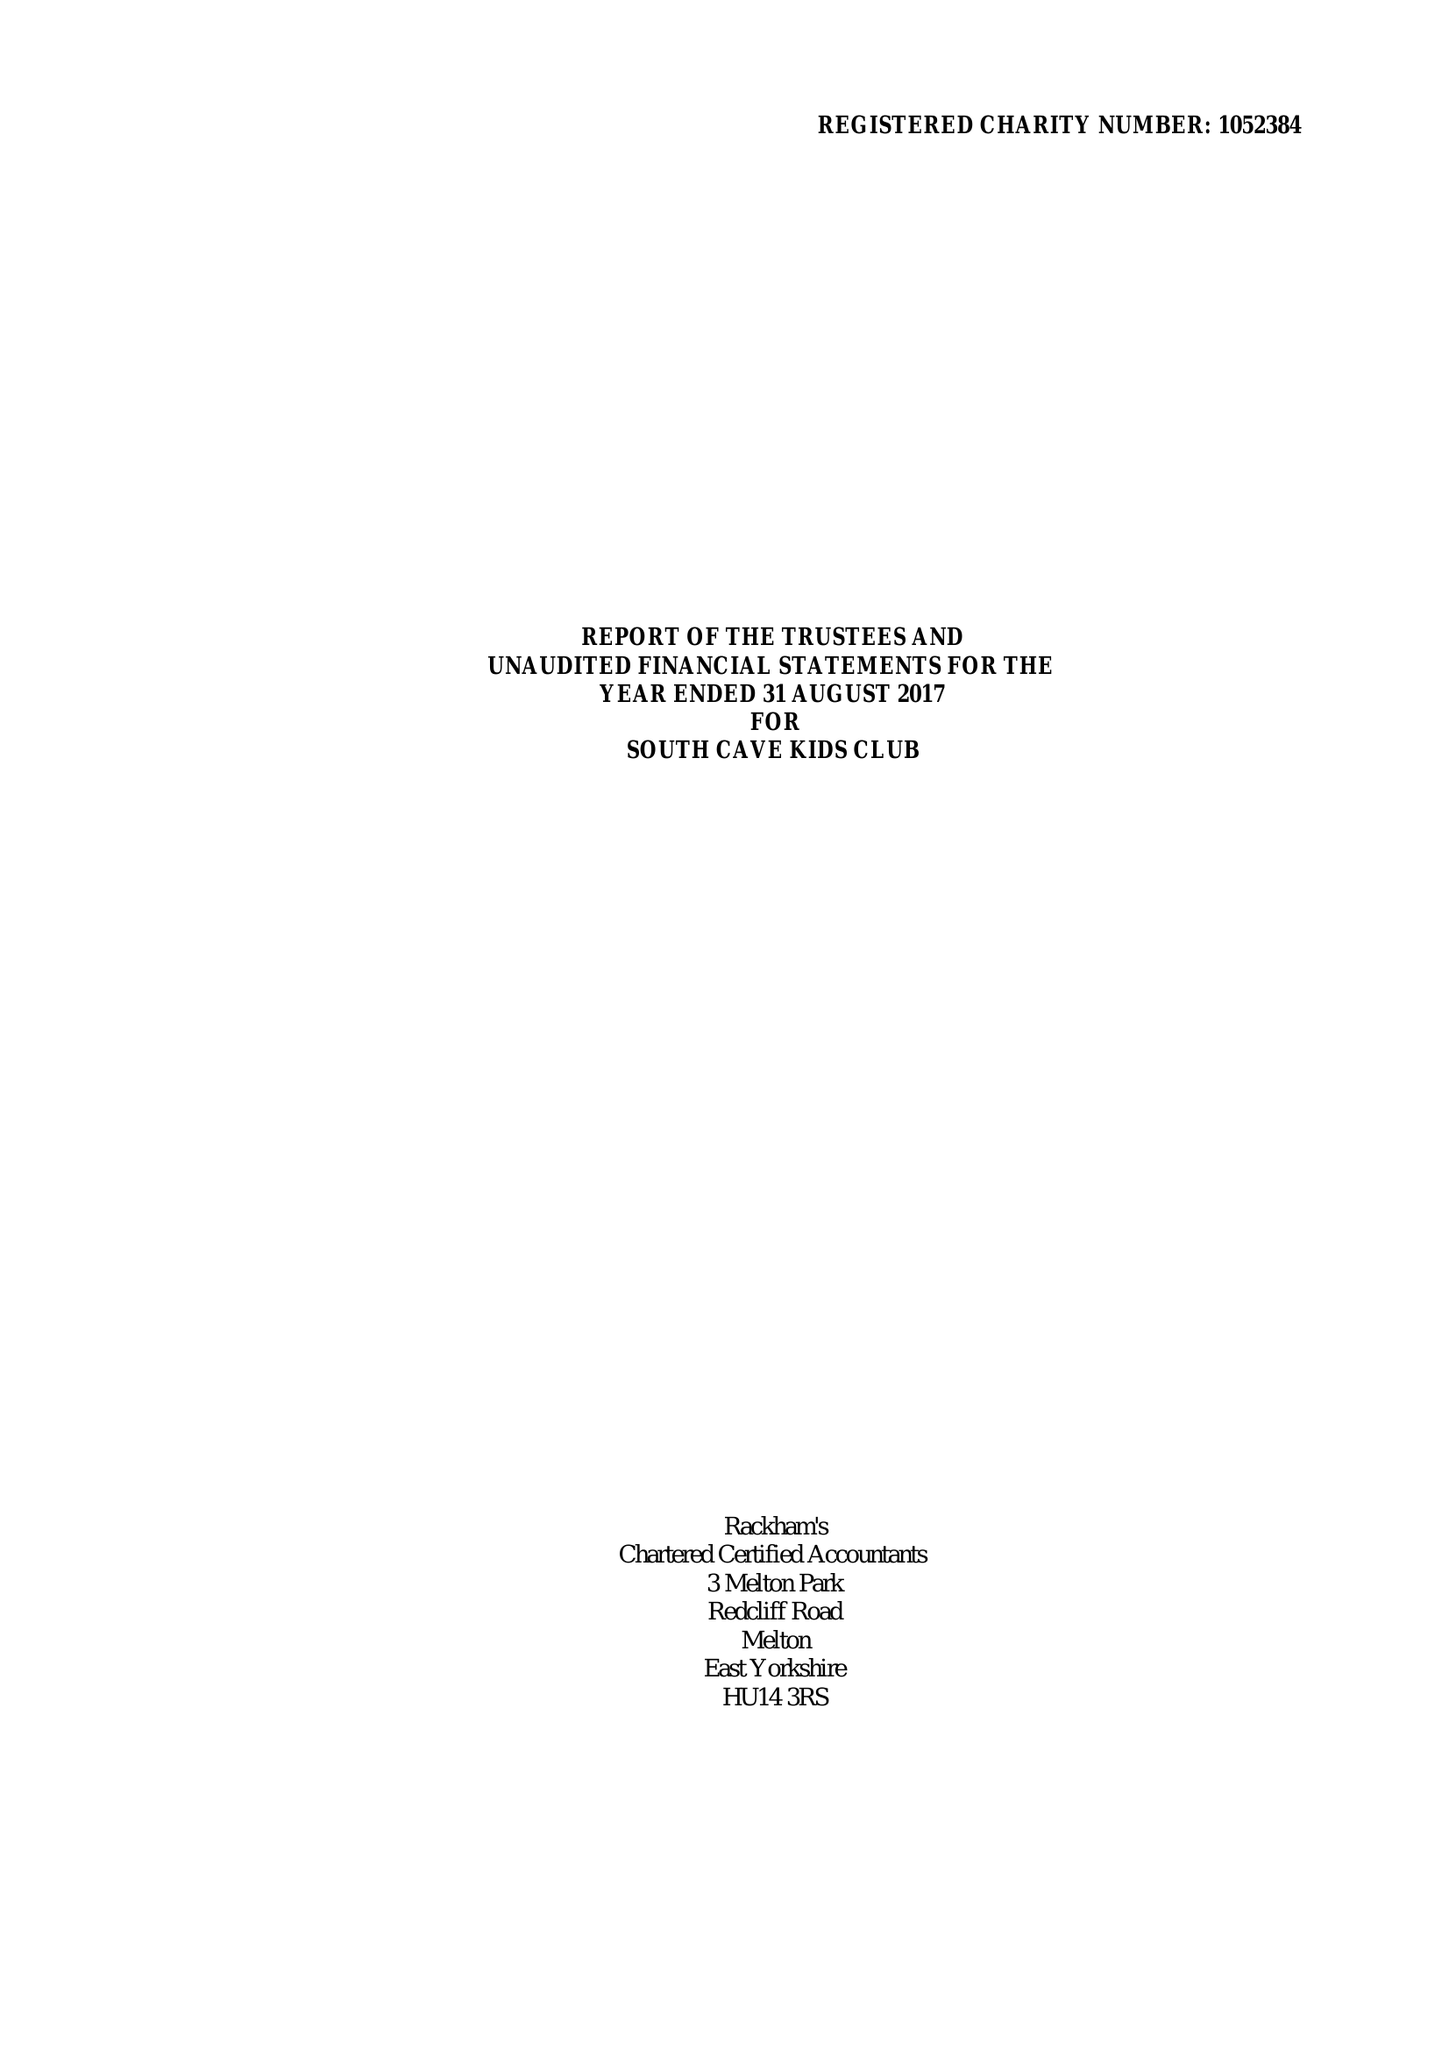What is the value for the address__postcode?
Answer the question using a single word or phrase. HU15 2EP 